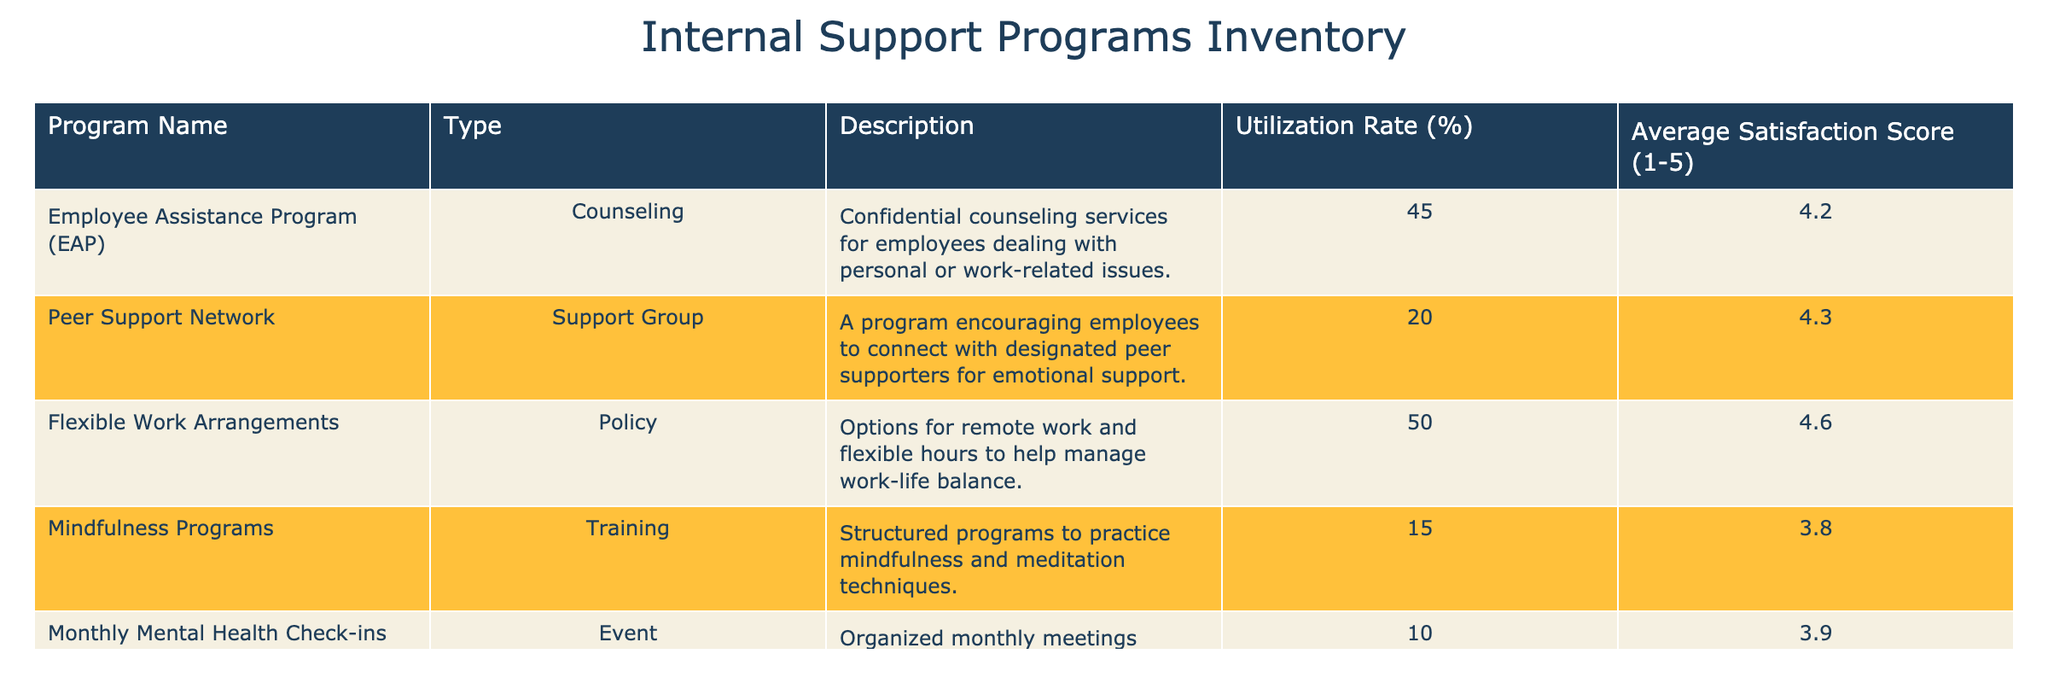What is the utilization rate of the Employee Assistance Program? The utilization rate for the Employee Assistance Program is directly stated in the table as 45%.
Answer: 45% Which program has the highest average satisfaction score? To find the program with the highest average satisfaction score, we compare the scores listed for each program. The Flexible Work Arrangements program has the highest score at 4.6.
Answer: Flexible Work Arrangements Is the utilization rate of the Peer Support Network lower than the Mindfulness Programs? The utilization rate for the Peer Support Network is 20%, while the rate for the Mindfulness Programs is 15%. Since 20% is greater than 15%, the statement is false.
Answer: No What is the average utilization rate of all programs? To find the average utilization rate, sum the utilization rates of all programs (45 + 20 + 50 + 15 + 10 = 140) and divide by the total number of programs (5). Thus, the average utilization rate is 140 / 5 = 28%.
Answer: 28% How many programs have a utilization rate equal to or above 40%? The programs with a utilization rate of 40% or above are Employee Assistance Program (45%) and Flexible Work Arrangements (50%). Counting these, there are two programs.
Answer: 2 What is the average satisfaction score for programs with a utilization rate below 20%? First, identify the programs with a utilization rate under 20%, which is only the Mindfulness Programs (15%) and Monthly Mental Health Check-ins (10%). The average satisfaction score for these two programs is calculated as (3.8 + 3.9) / 2 = 3.85.
Answer: 3.85 Do Flexible Work Arrangements provide a higher satisfaction score compared to the Monthly Mental Health Check-ins? The Flexible Work Arrangements program has an average satisfaction score of 4.6. The Monthly Mental Health Check-ins has a score of 3.9. Since 4.6 is greater than 3.9, the statement is true.
Answer: Yes What is the difference in utilization rates between the Employee Assistance Program and the Monthly Mental Health Check-ins? The Employee Assistance Program’s utilization rate is 45%, and the Monthly Mental Health Check-ins’ rate is 10%. The difference is calculated as 45% - 10% = 35%.
Answer: 35% 